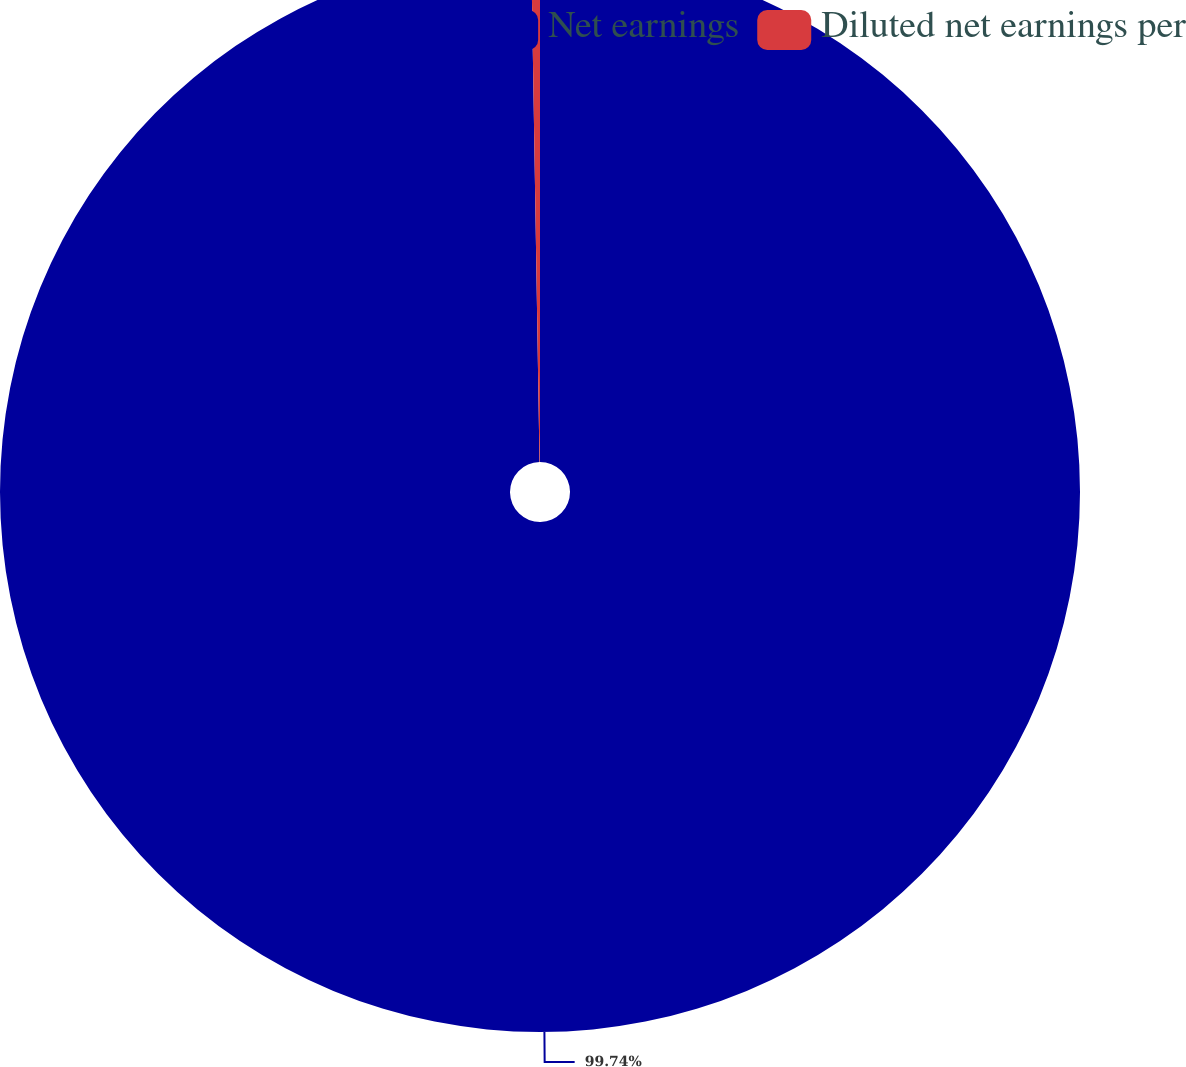Convert chart to OTSL. <chart><loc_0><loc_0><loc_500><loc_500><pie_chart><fcel>Net earnings<fcel>Diluted net earnings per<nl><fcel>99.74%<fcel>0.26%<nl></chart> 